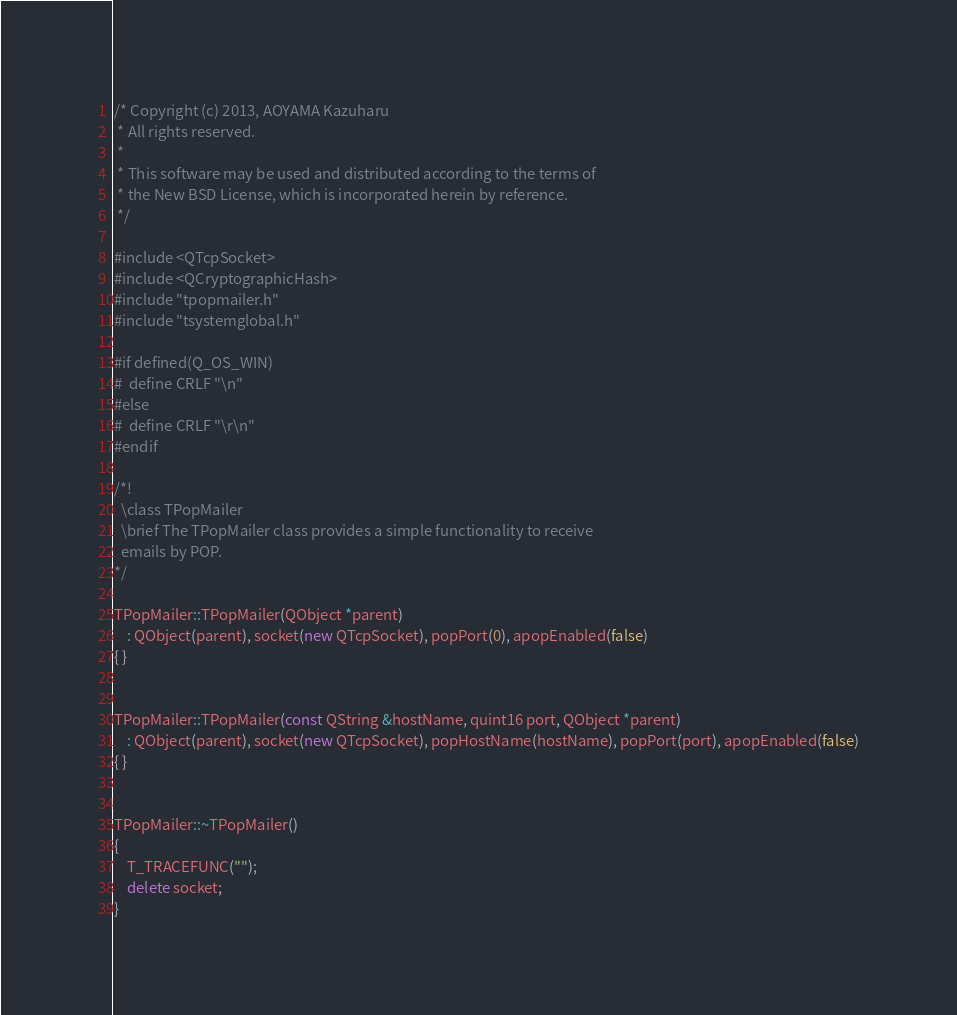<code> <loc_0><loc_0><loc_500><loc_500><_C++_>/* Copyright (c) 2013, AOYAMA Kazuharu
 * All rights reserved.
 *
 * This software may be used and distributed according to the terms of
 * the New BSD License, which is incorporated herein by reference.
 */

#include <QTcpSocket>
#include <QCryptographicHash>
#include "tpopmailer.h"
#include "tsystemglobal.h"

#if defined(Q_OS_WIN)
#  define CRLF "\n"
#else
#  define CRLF "\r\n"
#endif

/*!
  \class TPopMailer
  \brief The TPopMailer class provides a simple functionality to receive
  emails by POP.
*/

TPopMailer::TPopMailer(QObject *parent)
    : QObject(parent), socket(new QTcpSocket), popPort(0), apopEnabled(false)
{ }


TPopMailer::TPopMailer(const QString &hostName, quint16 port, QObject *parent)
    : QObject(parent), socket(new QTcpSocket), popHostName(hostName), popPort(port), apopEnabled(false)
{ }


TPopMailer::~TPopMailer()
{
    T_TRACEFUNC("");
    delete socket;
}

</code> 